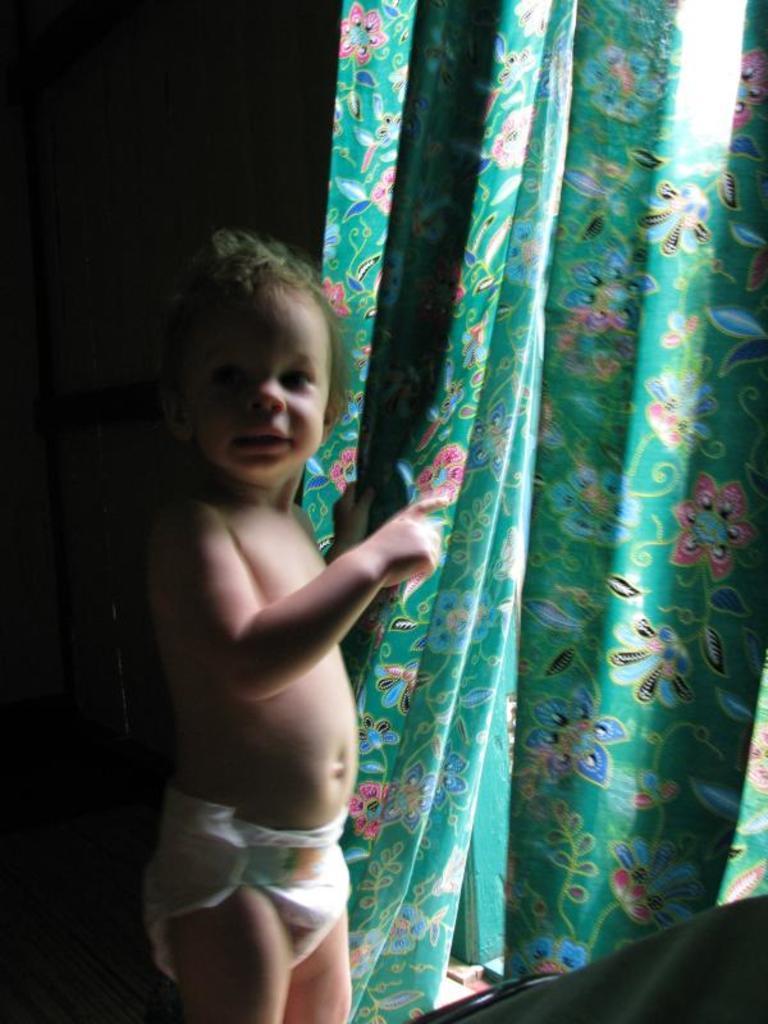Describe this image in one or two sentences. In this image we can see there is a child standing and holding the curtain. In front of him it looks like an object and the dark background. 